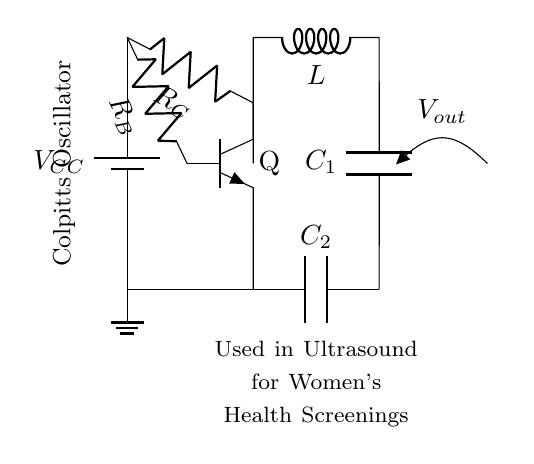What is the type of oscillator represented in the circuit? The circuit diagram specifically identifies itself as a Colpitts Oscillator, which is labeled in the diagram.
Answer: Colpitts Oscillator What components are connected to the transistor's collector? The collector of the transistor (Q) is connected to a resistor (R_C) and an inductor (L), indicated by the lines drawn in the circuit.
Answer: Resistor and inductor What is the purpose of the capacitors in this circuit? The capacitors (C_1 and C_2) in a Colpitts Oscillator are used to determine the frequency of oscillation; they create a resonant circuit along with the inductor.
Answer: Frequency determination What is the output voltage labeled as in the circuit? The output voltage in the circuit is labeled as V_out, which signifies the voltage that is taken from the output stage of the oscillator.
Answer: V_out How many resistors are present in the circuit? In examining the circuit diagram, there are two resistors, R_C and R_B, defined by the connections shown.
Answer: Two resistors What is the relationship between the capacitors and the inductor in this oscillator? In a Colpitts Oscillator, the capacitors and inductor work together to form a tank circuit that generates oscillations. The values of these components define the oscillation frequency.
Answer: Tank circuit Where is the ground connection in the circuit? The ground connection is clearly marked at the bottom of the circuit, where the point is connected to the circuit's negative reference.
Answer: Bottom left 